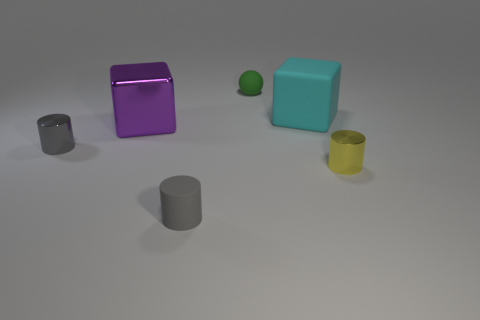Add 3 large things. How many objects exist? 9 Subtract all balls. How many objects are left? 5 Add 5 green balls. How many green balls exist? 6 Subtract 0 brown cylinders. How many objects are left? 6 Subtract all small gray things. Subtract all small gray cylinders. How many objects are left? 2 Add 5 tiny gray metallic things. How many tiny gray metallic things are left? 6 